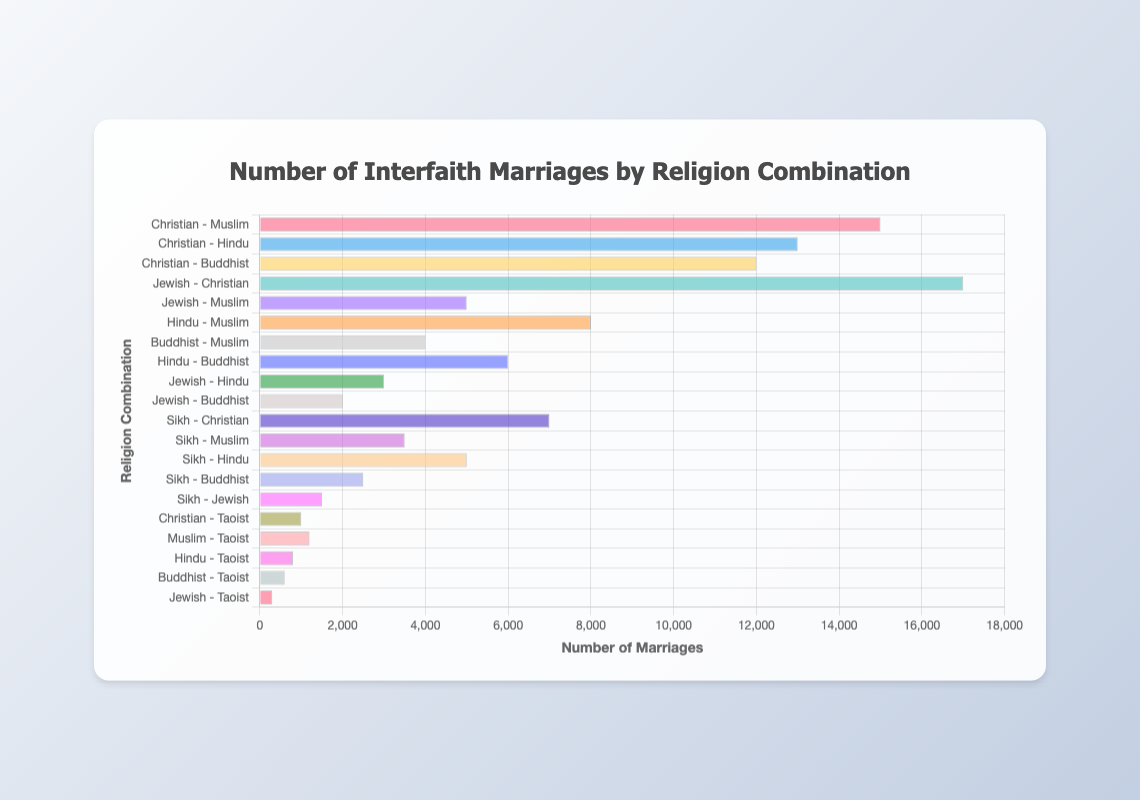Which religion combination has the highest number of interfaith marriages? The bar chart shows that "Jewish - Christian" has the highest value with 17,000 marriages, which is the longest bar in the chart.
Answer: Jewish - Christian Which religion combination has the lowest number of interfaith marriages? The bar chart shows that "Jewish - Taoist" has the lowest value with 300 marriages, which is the shortest bar in the chart.
Answer: Jewish - Taoist How much greater is the number of Christian-Muslim marriages compared to Hindu-Muslim marriages? The number of Christian-Muslim marriages is 15,000, and the number of Hindu-Muslim marriages is 8,000. The difference is 15,000 - 8,000 = 7,000.
Answer: 7,000 What is the combined total of Hindu-Buddhist and Buddhist-Taoist marriages? The number of Hindu-Buddhist marriages is 6,000 and the number of Buddhist-Taoist marriages is 600. The combined total is 6,000 + 600 = 6,600.
Answer: 6,600 Which has more interfaith marriages, Christian-Hindu or Sikh-Christian? The number of Christian-Hindu marriages is 13,000 and the number of Sikh-Christian marriages is 7,000. Therefore, Christian-Hindu has more interfaith marriages.
Answer: Christian - Hindu What is the median value of the number of interfaith marriages presented? The values sorted are: 300, 600, 800, 1,000, 1,200, 1,500, 2,000, 2,500, 3,000, 3,500, 4,000, 5,000, 5,000, 6,000, 7,000, 8,000, 12,000, 13,000, 15,000, 17,000. The median value is the average of the 10th and 11th values (sorted), which are both 3,500 and 4,000: (3,500 + 4,000) / 2 = 3,750.
Answer: 3,750 How many more interfaith marriages are there between Christians and Buddhists compared to Jews and Buddhists? The number of Christian-Buddhist marriages is 12,000, and the number of Jewish-Buddhist marriages is 2,000. The difference is 12,000 - 2,000 = 10,000.
Answer: 10,000 Which religion combination has the smallest number of interfaith marriages involving a Jewish partner? The smallest number of interfaith marriages involving a Jewish partner on the chart is "Jewish - Taoist" with 300 marriages.
Answer: Jewish - Taoist How does the number of Jewish-Muslim marriages compare to Sikh-Hindu marriages? The number of Jewish-Muslim marriages is 5,000, and the number of Sikh-Hindu marriages is also 5,000. They are equal.
Answer: Equal What is the total number of interfaith marriages involving a Taoist partner? The combinations involving Taoist partners are: Christian-Taoist (1,000), Muslim-Taoist (1,200), Hindu-Taoist (800), Buddhist-Taoist (600), and Jewish-Taoist (300). Their total is 1,000 + 1,200 + 800 + 600 + 300 = 3,900.
Answer: 3,900 